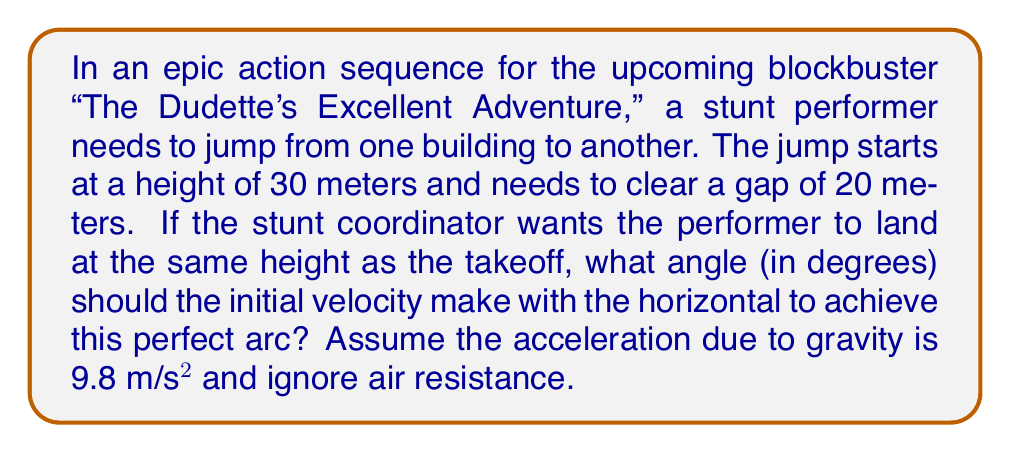Can you solve this math problem? Let's approach this step-by-step:

1) This scenario describes a projectile motion problem. We can use the equation:

   $$y = x \tan \theta - \frac{gx^2}{2v_0^2 \cos^2 \theta}$$

   Where:
   - $y$ is the vertical displacement (0 in this case as the start and end heights are the same)
   - $x$ is the horizontal displacement (20 meters)
   - $\theta$ is the angle we're solving for
   - $g$ is the acceleration due to gravity (9.8 m/s²)
   - $v_0$ is the initial velocity (which we don't need to know for this problem)

2) Substituting our known values:

   $$0 = 20 \tan \theta - \frac{9.8 \cdot 20^2}{2v_0^2 \cos^2 \theta}$$

3) Simplify:

   $$0 = 20 \tan \theta - \frac{3920}{2v_0^2 \cos^2 \theta}$$

4) Multiply both sides by $2v_0^2 \cos^2 \theta$:

   $$0 = 40v_0^2 \tan \theta \cos^2 \theta - 3920$$

5) Use the identity $\tan \theta \cos^2 \theta = \frac{1}{2} \sin 2\theta$:

   $$0 = 20v_0^2 \sin 2\theta - 3920$$

6) Solve for $\sin 2\theta$:

   $$\sin 2\theta = \frac{3920}{20v_0^2} = \frac{196}{v_0^2}$$

7) For this to be possible, $\sin 2\theta$ must equal 1 (its maximum value), so:

   $$1 = \frac{196}{v_0^2}$$
   $$v_0^2 = 196$$
   $$v_0 = 14 \text{ m/s}$$

8) If $\sin 2\theta = 1$, then $2\theta = 90°$, so $\theta = 45°$

Therefore, the angle should be 45° to achieve the perfect arc.
Answer: 45° 